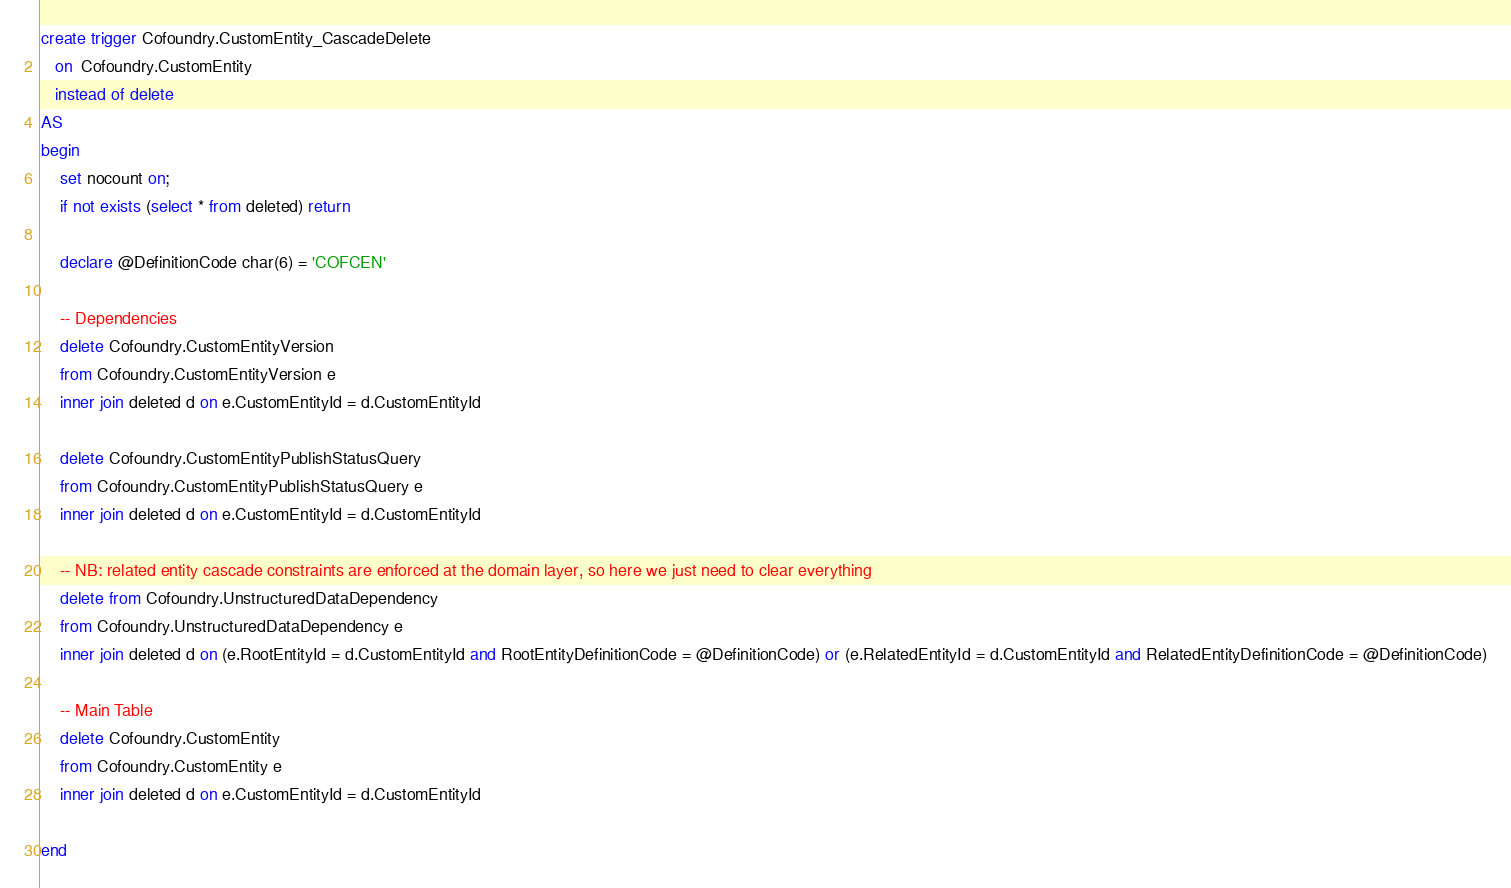<code> <loc_0><loc_0><loc_500><loc_500><_SQL_>create trigger Cofoundry.CustomEntity_CascadeDelete
   on  Cofoundry.CustomEntity
   instead of delete
AS 
begin
	set nocount on;
	if not exists (select * from deleted) return
	
	declare @DefinitionCode char(6) = 'COFCEN'

	-- Dependencies
    delete Cofoundry.CustomEntityVersion
	from Cofoundry.CustomEntityVersion e
	inner join deleted d on e.CustomEntityId = d.CustomEntityId

    delete Cofoundry.CustomEntityPublishStatusQuery
	from Cofoundry.CustomEntityPublishStatusQuery e
	inner join deleted d on e.CustomEntityId = d.CustomEntityId
		
	-- NB: related entity cascade constraints are enforced at the domain layer, so here we just need to clear everything
	delete from Cofoundry.UnstructuredDataDependency
	from Cofoundry.UnstructuredDataDependency e
	inner join deleted d on (e.RootEntityId = d.CustomEntityId and RootEntityDefinitionCode = @DefinitionCode) or (e.RelatedEntityId = d.CustomEntityId and RelatedEntityDefinitionCode = @DefinitionCode)

	-- Main Table
    delete Cofoundry.CustomEntity
	from Cofoundry.CustomEntity e
	inner join deleted d on e.CustomEntityId = d.CustomEntityId

end</code> 